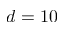<formula> <loc_0><loc_0><loc_500><loc_500>d = 1 0</formula> 